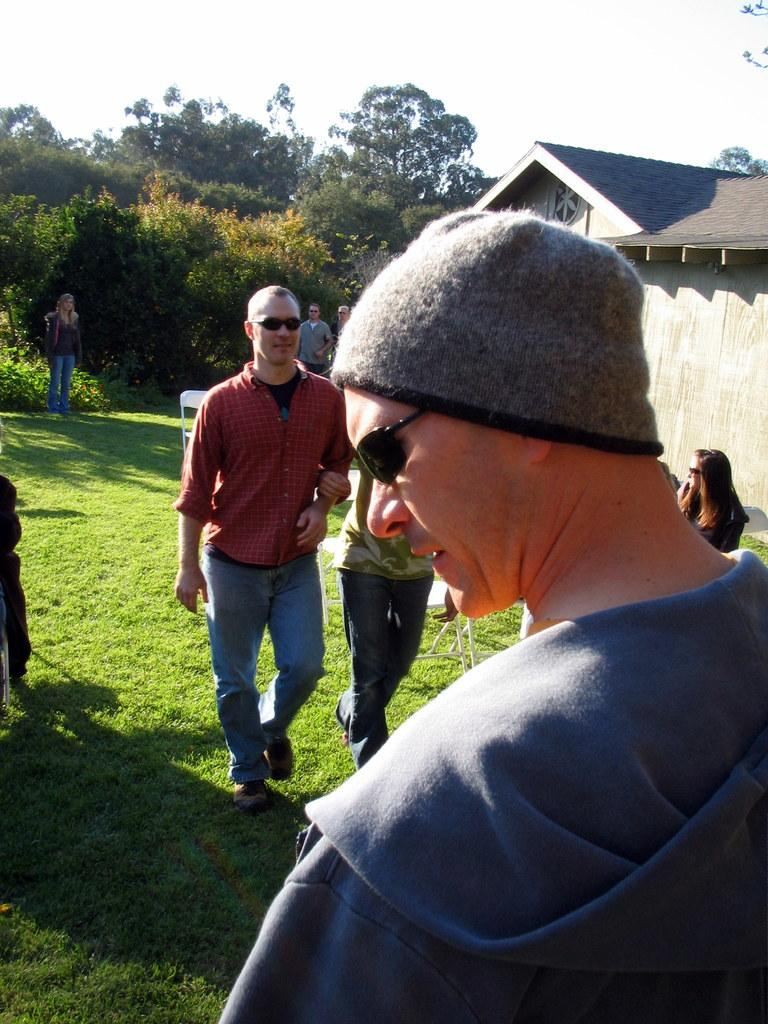What is the surface that the persons are on in the image? The persons are on the ground in the image. What type of vegetation is present in the image? There is grass in the image. What type of furniture can be seen in the image? There are chairs in the image. What can be seen in the background of the image? There are trees, a house, and the sky visible in the background of the image. What type of vegetable is being cooked on the ground in the image? There is no vegetable being cooked in the image; the persons are simply standing on the ground. 